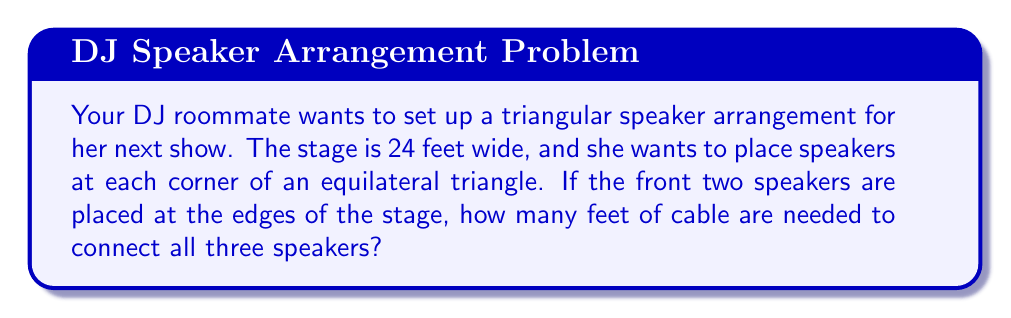Give your solution to this math problem. Let's approach this step-by-step:

1) First, we need to determine the side length of the equilateral triangle. The width of the stage (24 feet) is the base of our triangle.

2) In an equilateral triangle, the height (h) is related to the side length (s) by the formula:

   $$h = \frac{\sqrt{3}}{2}s$$

3) We also know that in our case, the base (b) is equal to the side length (s):

   $$b = s = 24$$

4) Using these, we can calculate the height:

   $$h = \frac{\sqrt{3}}{2} \cdot 24 = 12\sqrt{3}$$

5) Now we have an equilateral triangle with side length 24 feet. To connect all three speakers, we need to calculate the perimeter:

   $$\text{Perimeter} = 3s = 3 \cdot 24 = 72 \text{ feet}$$

6) Therefore, 72 feet of cable are needed to connect all three speakers.

[asy]
unitsize(0.15cm);
pair A = (0,0), B = (24,0), C = (12,12*sqrt(3));
draw(A--B--C--A);
label("24'", (B+A)/2, S);
label("24'", (C+B)/2, SE);
label("24'", (A+C)/2, NW);
label("A", A, SW);
label("B", B, SE);
label("C", C, N);
[/asy]
Answer: 72 feet 